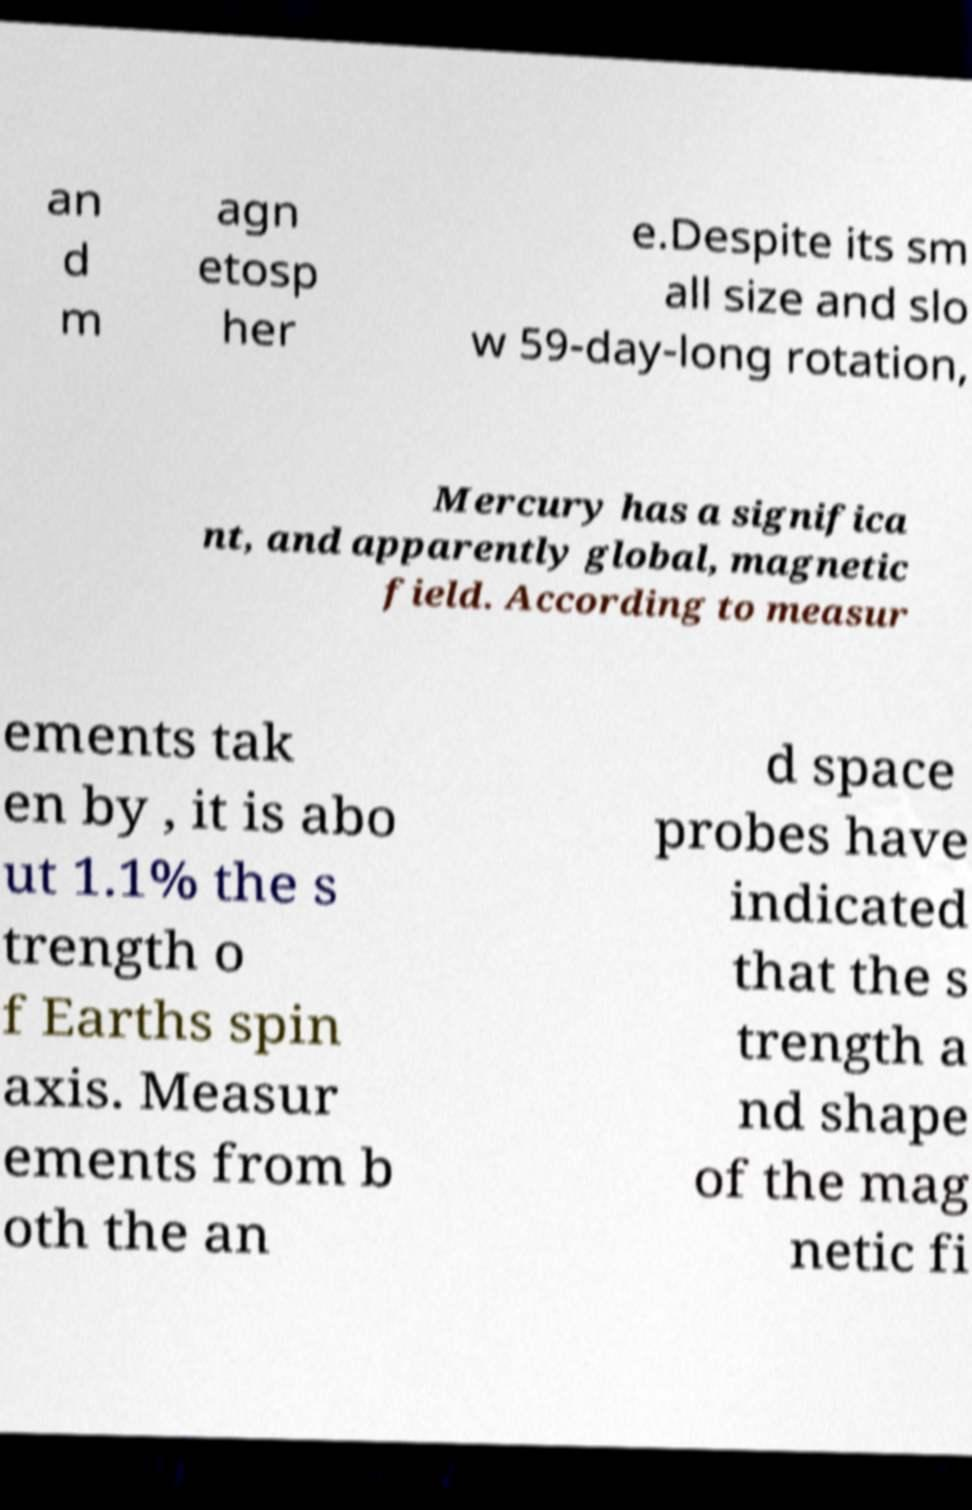Can you read and provide the text displayed in the image?This photo seems to have some interesting text. Can you extract and type it out for me? an d m agn etosp her e.Despite its sm all size and slo w 59-day-long rotation, Mercury has a significa nt, and apparently global, magnetic field. According to measur ements tak en by , it is abo ut 1.1% the s trength o f Earths spin axis. Measur ements from b oth the an d space probes have indicated that the s trength a nd shape of the mag netic fi 